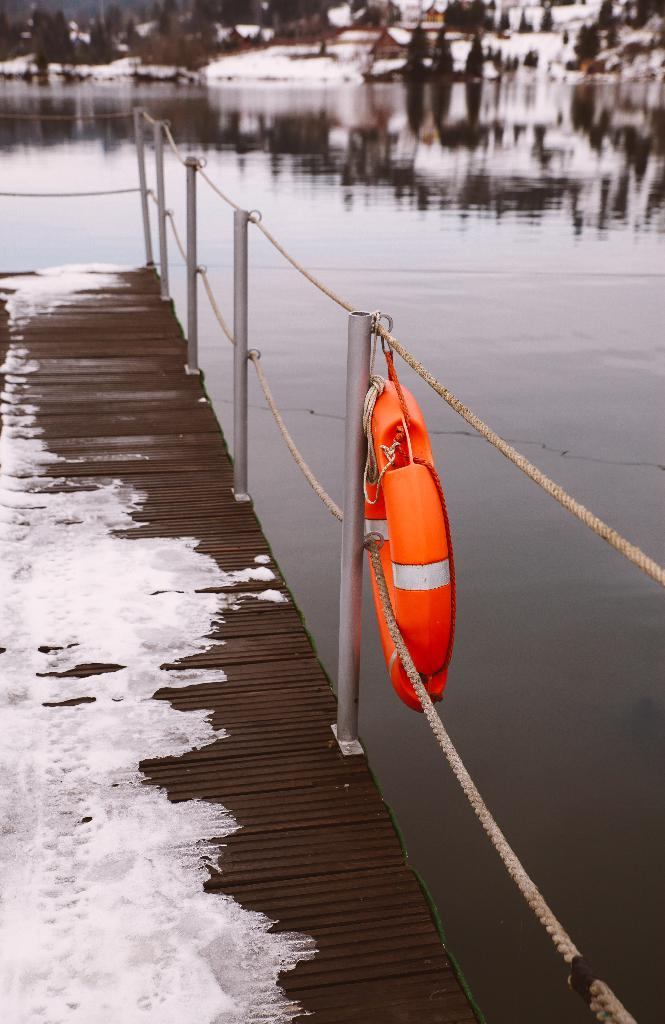What type of barrier can be seen in the image? There is a fence in the image. What kind of surface is present in the image? There is a wooden surface in the image. What natural element is visible in the image? There is water visible in the image. What type of vegetation is present in the image? There are trees in the image. Can you describe any other objects in the image? There are other unspecified objects in the image. How many beads are hanging from the fence in the image? There are no beads present in the image; it only features a fence, a wooden surface, water, trees, and unspecified objects. Can you tell me how the horses are adjusting their stance in the image? There are no horses present in the image, so it is not possible to determine how they might be adjusting their stance. 